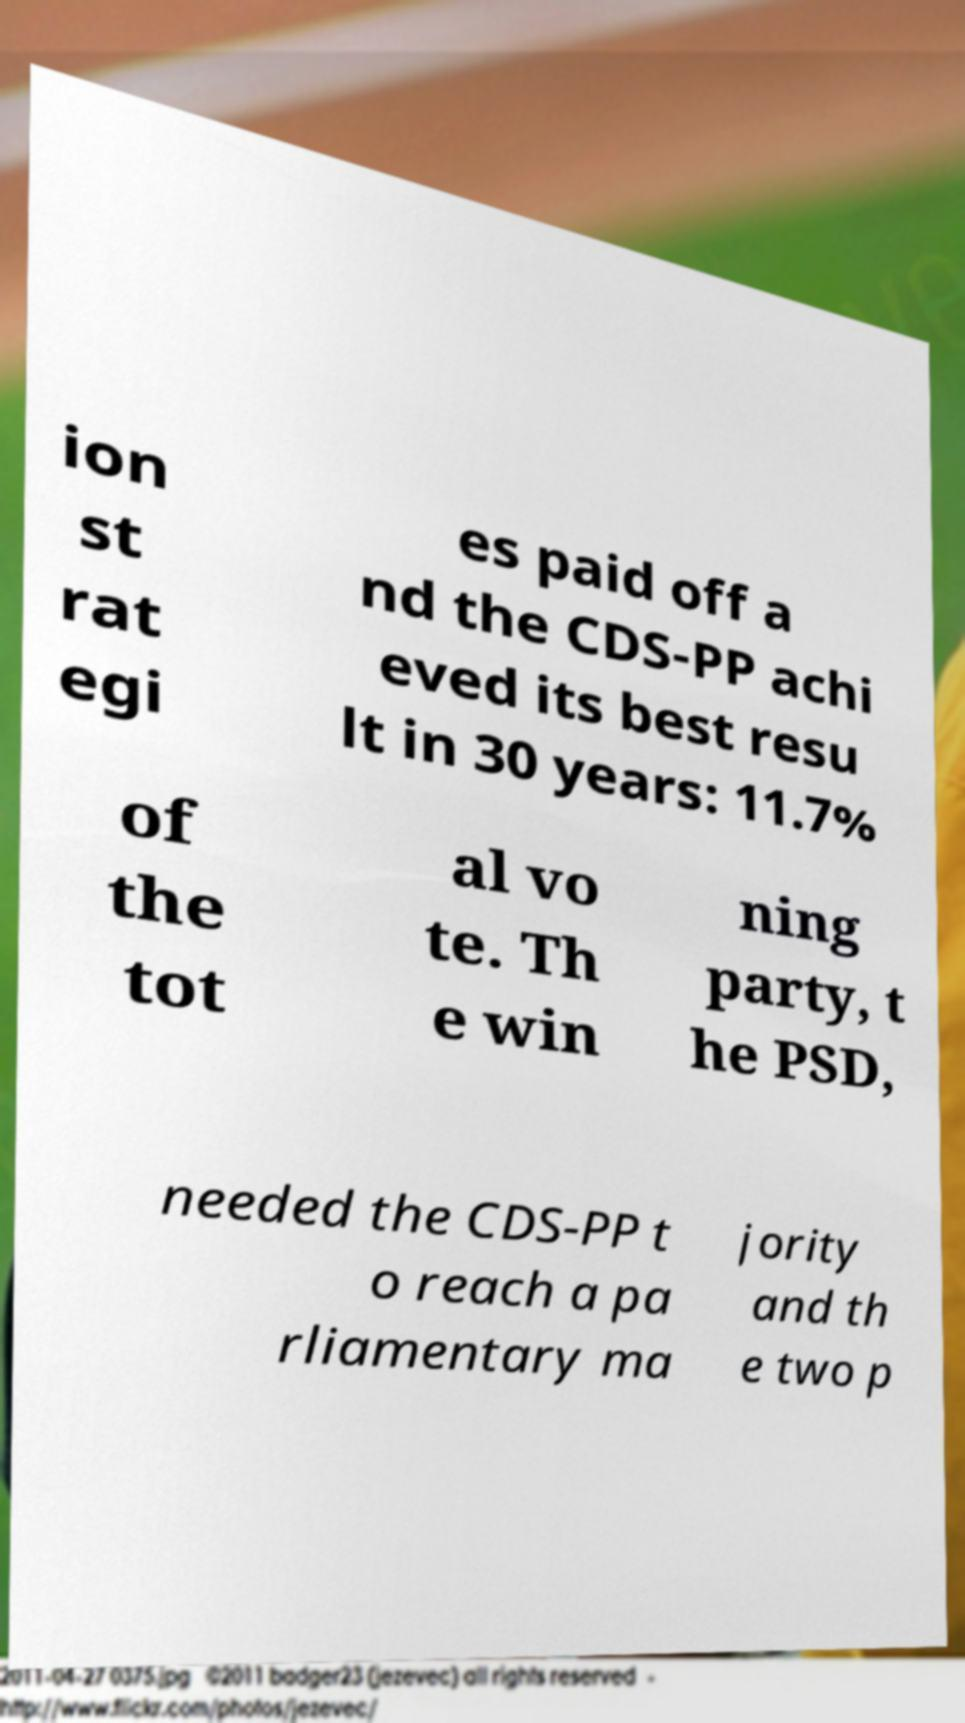What messages or text are displayed in this image? I need them in a readable, typed format. ion st rat egi es paid off a nd the CDS-PP achi eved its best resu lt in 30 years: 11.7% of the tot al vo te. Th e win ning party, t he PSD, needed the CDS-PP t o reach a pa rliamentary ma jority and th e two p 